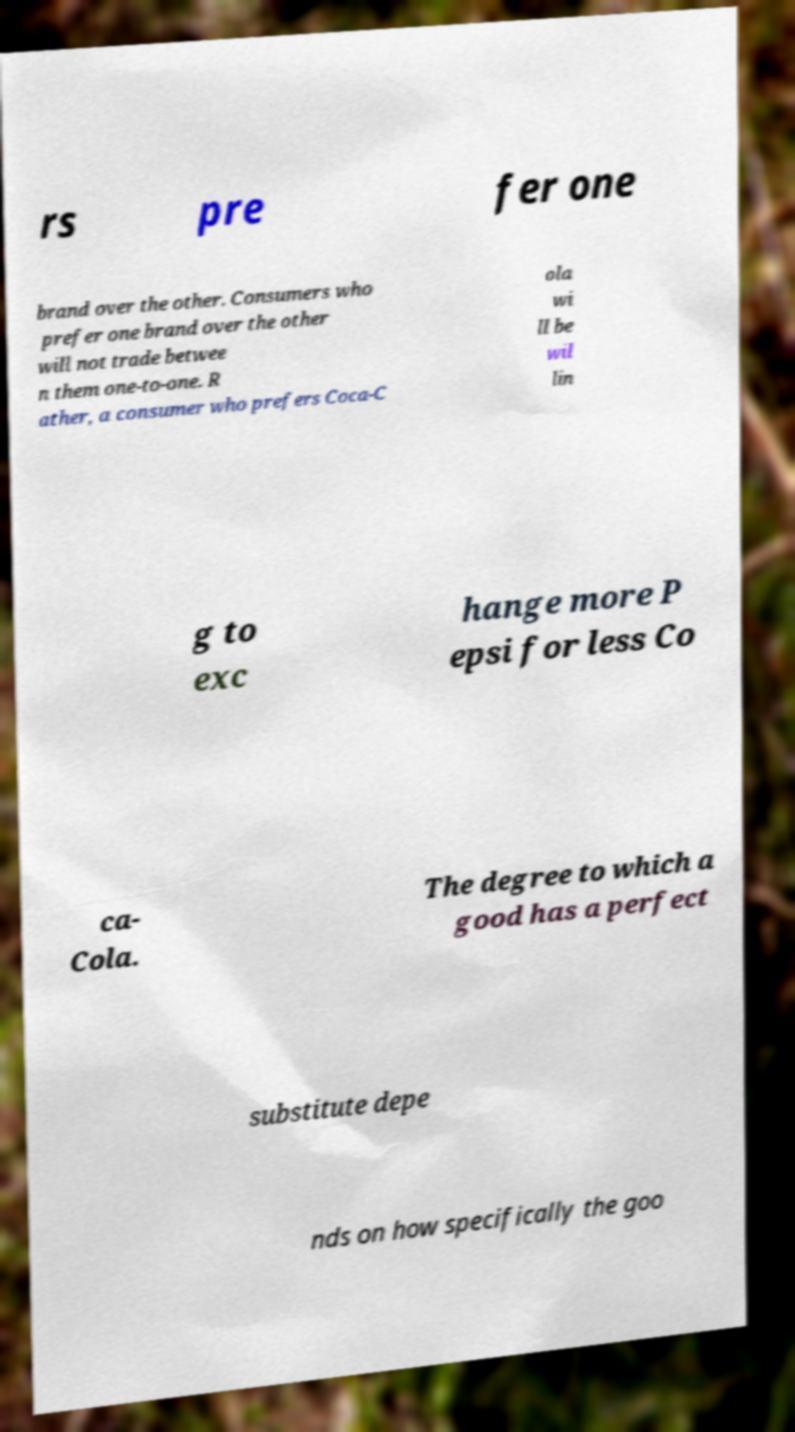Can you accurately transcribe the text from the provided image for me? rs pre fer one brand over the other. Consumers who prefer one brand over the other will not trade betwee n them one-to-one. R ather, a consumer who prefers Coca-C ola wi ll be wil lin g to exc hange more P epsi for less Co ca- Cola. The degree to which a good has a perfect substitute depe nds on how specifically the goo 